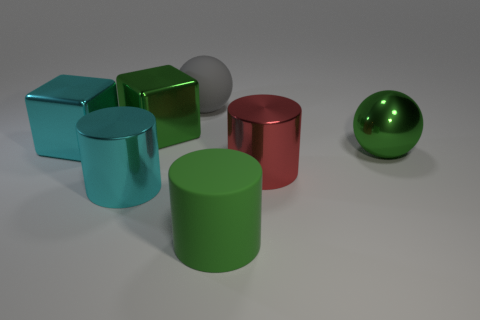Add 1 cyan metal cylinders. How many objects exist? 8 Subtract all cylinders. How many objects are left? 4 Subtract 0 blue cubes. How many objects are left? 7 Subtract all gray rubber balls. Subtract all large gray things. How many objects are left? 5 Add 4 big green matte cylinders. How many big green matte cylinders are left? 5 Add 7 big cubes. How many big cubes exist? 9 